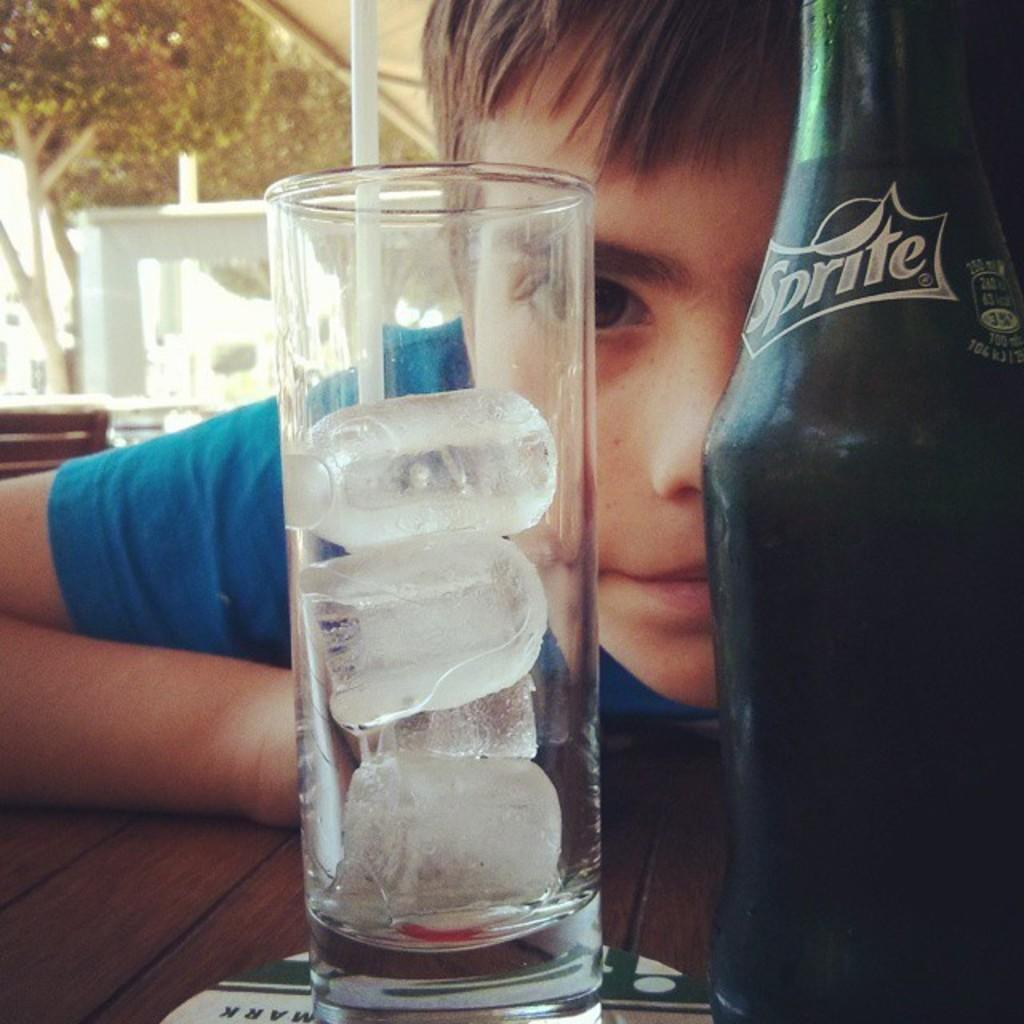What is the boy doing in the image? The boy is sitting in the image. What is located near the boy? There is a table in the image. What items can be seen on the table? There is a glass and a bottle on the table. What is visible in the background of the image? There is a glass wall and trees behind the glass wall in the background of the image. Can you see any balloons floating near the trees in the image? There are no balloons visible in the image; only a glass wall and trees can be seen in the background. 